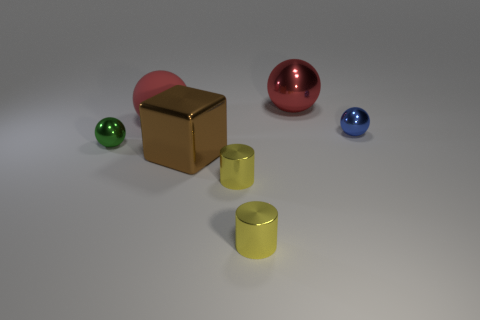Does the blue metal object have the same shape as the brown metal object?
Your response must be concise. No. Are there any shiny blocks on the right side of the tiny blue sphere?
Offer a terse response. No. How many things are either tiny cyan blocks or yellow cylinders?
Offer a terse response. 2. What number of other things are there of the same size as the red shiny thing?
Ensure brevity in your answer.  2. How many things are both behind the large red matte sphere and left of the red rubber ball?
Make the answer very short. 0. Does the red ball that is on the left side of the brown object have the same size as the shiny sphere that is in front of the blue sphere?
Make the answer very short. No. There is a blue sphere that is on the right side of the green metal thing; what is its size?
Offer a very short reply. Small. How many objects are objects that are to the right of the green metal sphere or metal things on the left side of the red rubber ball?
Your answer should be compact. 7. Are there any other things of the same color as the block?
Provide a short and direct response. No. Are there the same number of rubber things that are to the left of the small green metallic sphere and large objects that are behind the red shiny object?
Make the answer very short. Yes. 